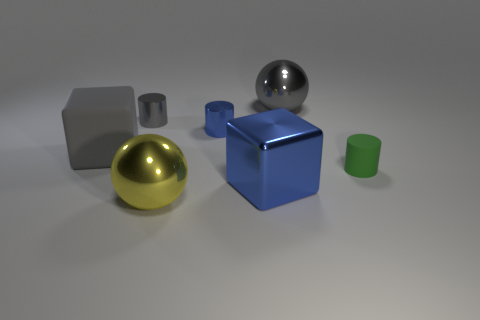The tiny object that is the same color as the large metallic cube is what shape?
Provide a short and direct response. Cylinder. Do the yellow object and the gray rubber block have the same size?
Keep it short and to the point. Yes. How many big blocks are both behind the blue cube and right of the yellow metal object?
Provide a succinct answer. 0. Do the blue block and the ball on the right side of the tiny blue object have the same material?
Provide a succinct answer. Yes. How many blue objects are either cylinders or rubber blocks?
Your answer should be very brief. 1. Is there a green rubber object of the same size as the blue shiny cylinder?
Your answer should be very brief. Yes. What material is the sphere that is to the left of the gray sphere that is behind the big gray object that is left of the large yellow thing?
Your answer should be compact. Metal. Are there the same number of large rubber cubes to the right of the blue metal block and gray spheres?
Keep it short and to the point. No. Does the block to the left of the big blue metallic block have the same material as the gray thing behind the gray metal cylinder?
Offer a very short reply. No. How many things are either tiny gray metallic things or gray shiny things behind the gray cylinder?
Make the answer very short. 2. 